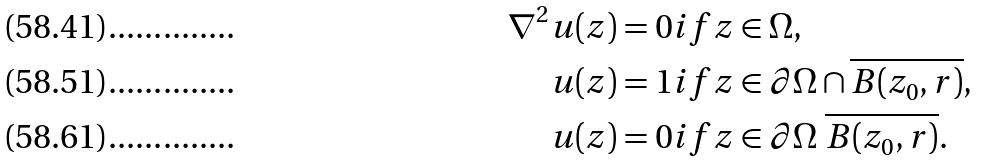Convert formula to latex. <formula><loc_0><loc_0><loc_500><loc_500>\nabla ^ { 2 } u ( z ) & = 0 i f z \in \Omega , \\ u ( z ) & = 1 i f z \in \partial \Omega \cap \overline { B ( z _ { 0 } , r ) } , \\ u ( z ) & = 0 i f z \in \partial \Omega \ \overline { B ( z _ { 0 } , r ) } .</formula> 